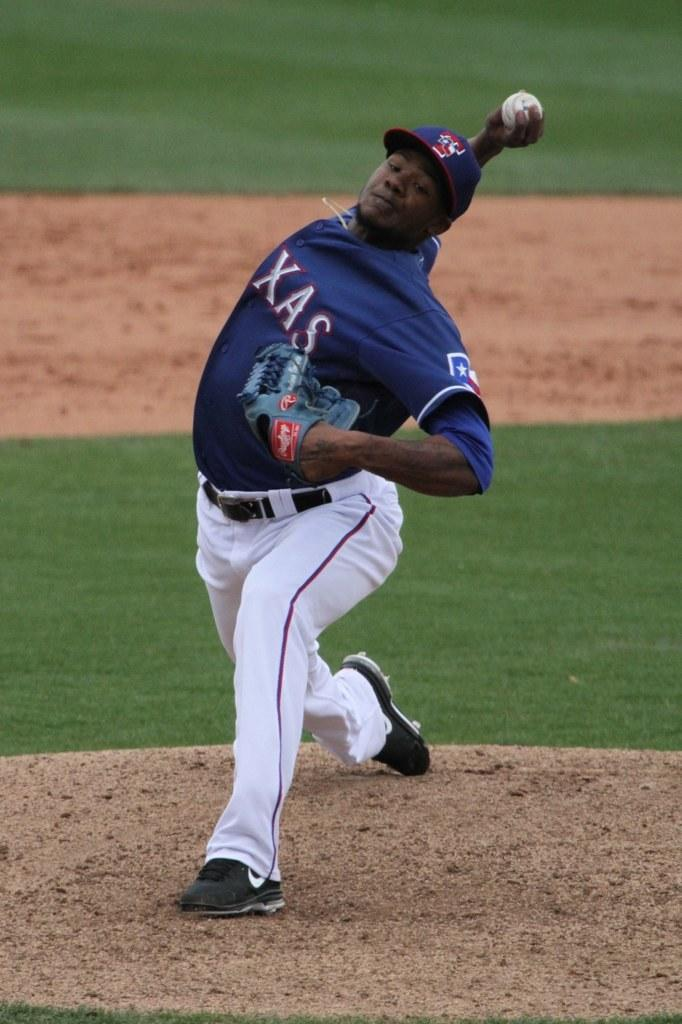<image>
Provide a brief description of the given image. A pitcher in a TEXAS uniform winds up for a throw. 